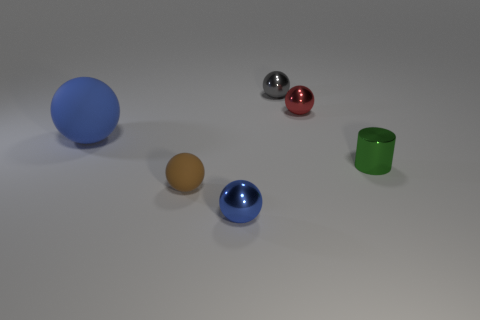Subtract 1 balls. How many balls are left? 4 Subtract all brown balls. How many balls are left? 4 Add 1 blue balls. How many objects exist? 7 Subtract all blue shiny spheres. How many spheres are left? 4 Subtract all red spheres. Subtract all purple blocks. How many spheres are left? 4 Subtract all spheres. How many objects are left? 1 Subtract 1 green cylinders. How many objects are left? 5 Subtract all tiny brown matte things. Subtract all yellow cubes. How many objects are left? 5 Add 3 brown matte things. How many brown matte things are left? 4 Add 1 gray metal balls. How many gray metal balls exist? 2 